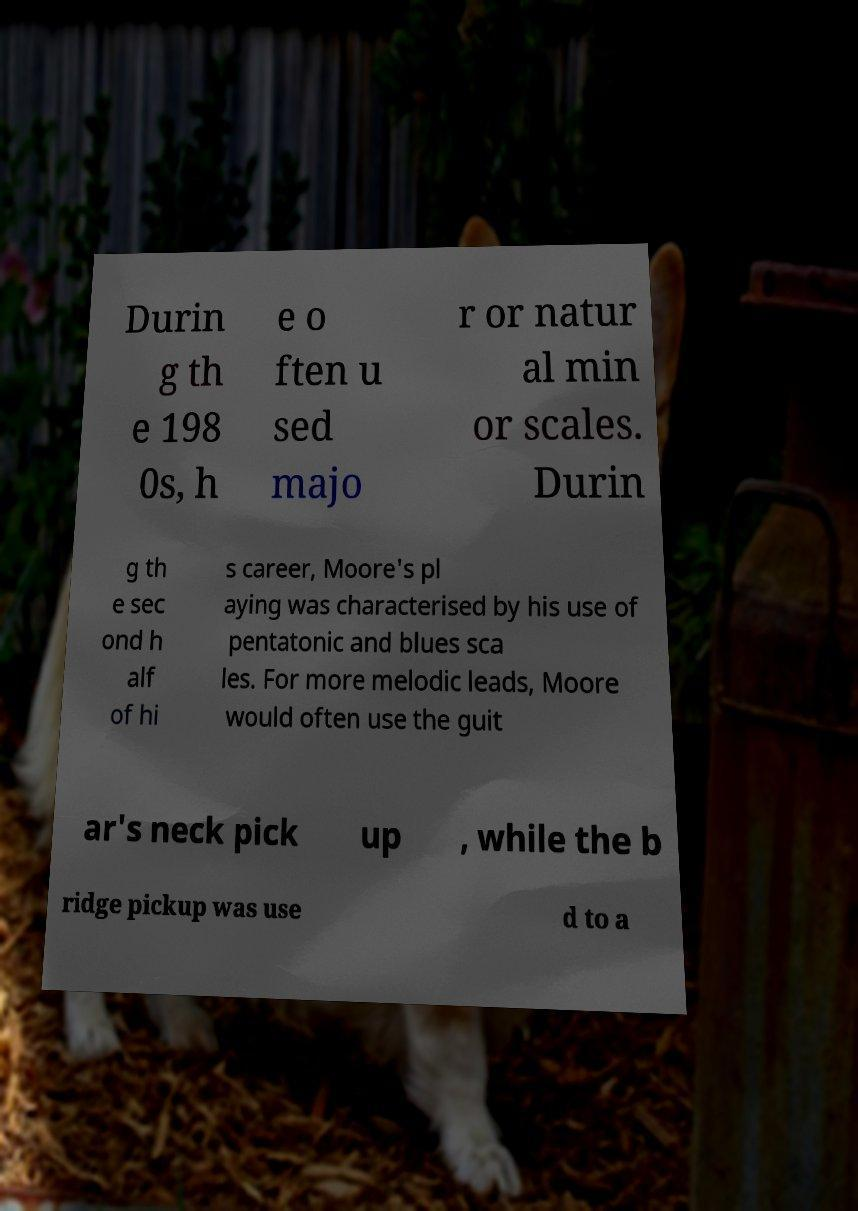Could you extract and type out the text from this image? Durin g th e 198 0s, h e o ften u sed majo r or natur al min or scales. Durin g th e sec ond h alf of hi s career, Moore's pl aying was characterised by his use of pentatonic and blues sca les. For more melodic leads, Moore would often use the guit ar's neck pick up , while the b ridge pickup was use d to a 